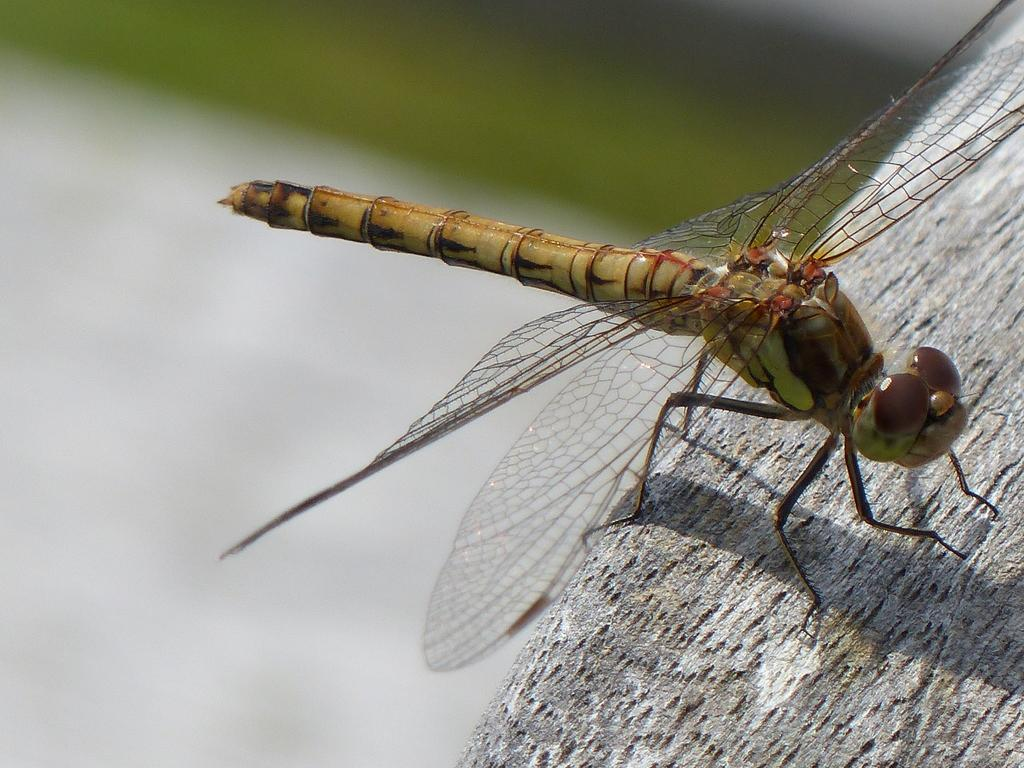What insect is present in the image? There is a dragonfly in the image. Where is the dragonfly located? The dragonfly is sitting on a tree. Can you describe the background of the image? The background of the image is blurred. What other object can be seen in the image? There is a tree visible to the right in the image. What type of men are represented in the image? There are no men present in the image; it features a dragonfly sitting on a tree. Can you tell me how many worms are visible in the image? There are no worms present in the image. 